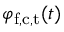<formula> <loc_0><loc_0><loc_500><loc_500>\varphi _ { f , c , t } ( t )</formula> 